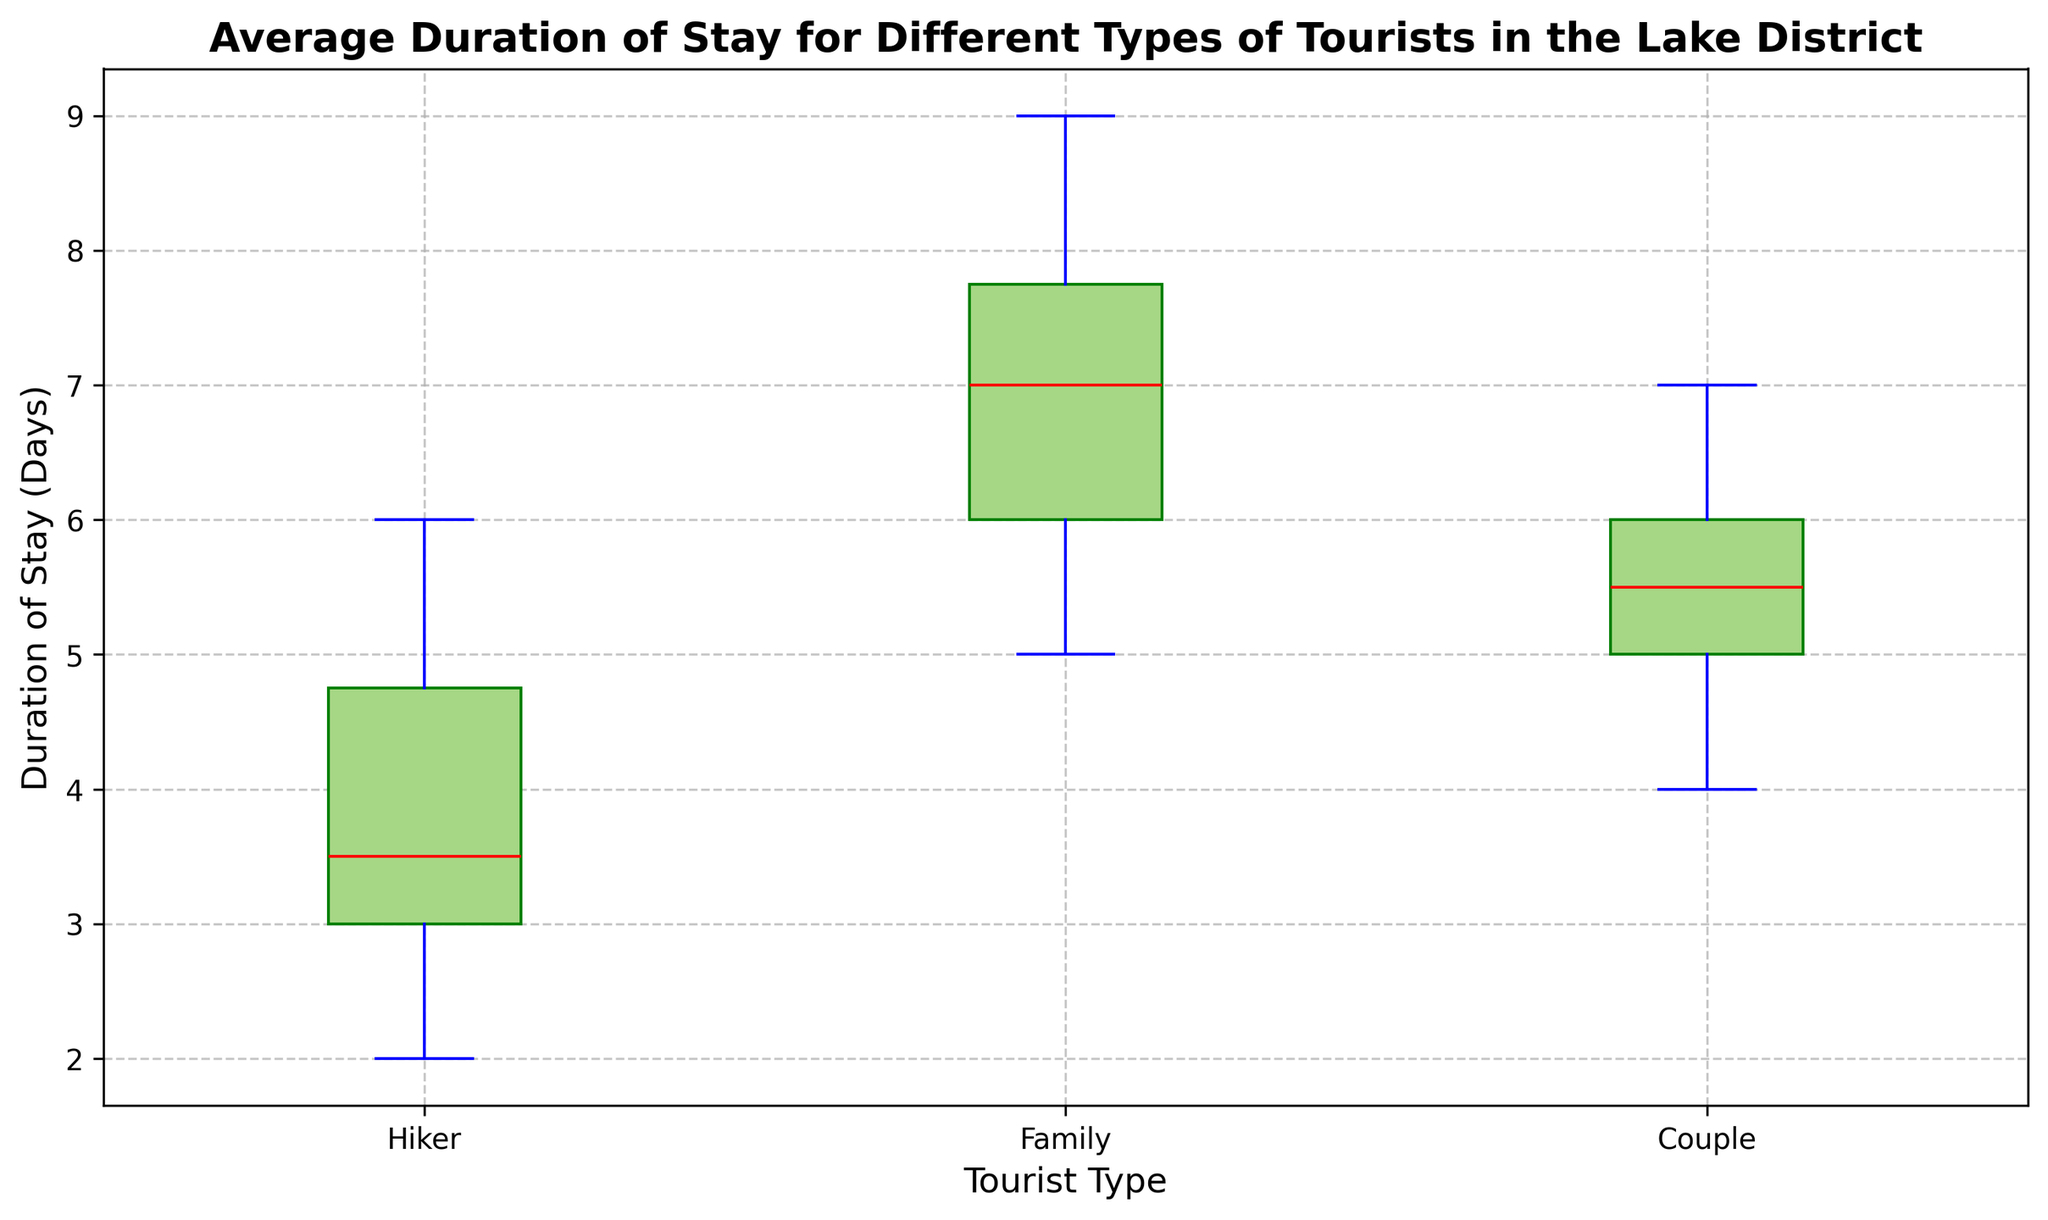What is the median duration of stay for families? Look at the box plot for the "Family" group and identify the red line inside the box, which represents the median.
Answer: 7 days Which type of tourist has the largest interquartile range (IQR) of stay duration? The IQR is represented by the length of the box. Compare the length of the boxes of "Hiker", "Family", and "Couple".
Answer: Families What is the range of the duration of stay for hikers? Identify the minimum and maximum values for the "Hiker" box plot (bottom and top whiskers) and calculate the difference between the maximum and minimum.
Answer: 4 days (6-2) Which group of tourists has the least variability in their duration of stay? The group with the smallest box (height) has the least variability. Compare the boxes of "Hiker", "Family", and "Couple".
Answer: Couples Which tourist type has the highest median stay duration? Look at the red lines in all boxes and compare their positions to identify which is highest.
Answer: Families Is there any group without outliers in their duration of stay? Review the box plots for "Hiker", "Family", and "Couple" and check for the presence of any red markers outside the whiskers, indicating outliers.
Answer: Yes, Couples How does the average stay duration of hikers compare to that of families? Although the box plots don't directly show averages, compare the central tendency (medians) and general distribution (IQR) between "Hiker" and "Family". Hikers have a lower median and smaller IQR than Families.
Answer: Lower Which group has the widest range in their duration of stay? Look at the span from the lowest whisker to the highest whisker across all groups and compare the widest.
Answer: Families What color represents the box of the hiker group? Identify the color used in the box plot for the hikers, as mentioned in the description of styles and attributes.
Answer: Green Inspect the outliers: Which group(s) have visible outliers, and how many? Scan each box plot for any red dots outside the whiskers; these dots represent the outliers.
Answer: Hikers (2 outliers) 